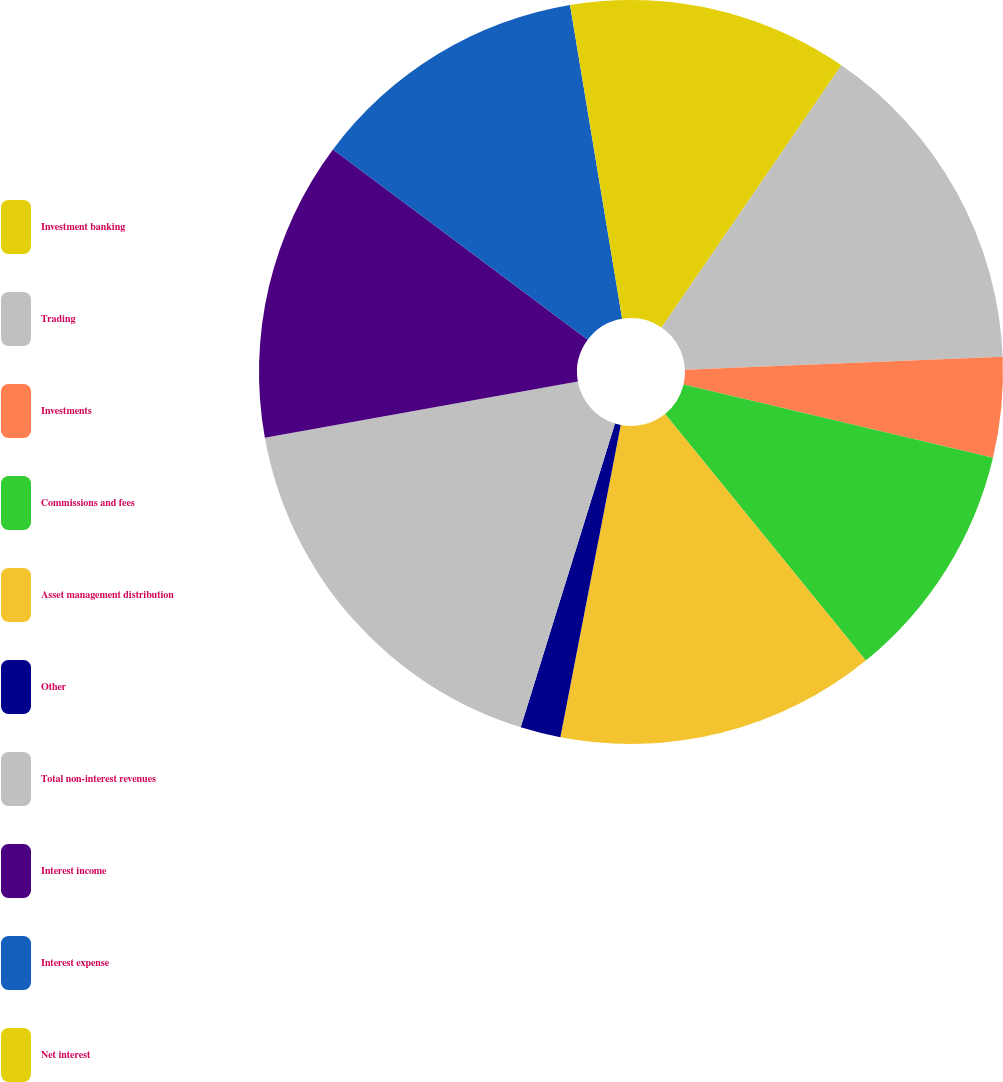Convert chart. <chart><loc_0><loc_0><loc_500><loc_500><pie_chart><fcel>Investment banking<fcel>Trading<fcel>Investments<fcel>Commissions and fees<fcel>Asset management distribution<fcel>Other<fcel>Total non-interest revenues<fcel>Interest income<fcel>Interest expense<fcel>Net interest<nl><fcel>9.57%<fcel>14.78%<fcel>4.35%<fcel>10.43%<fcel>13.91%<fcel>1.75%<fcel>17.38%<fcel>13.04%<fcel>12.17%<fcel>2.62%<nl></chart> 